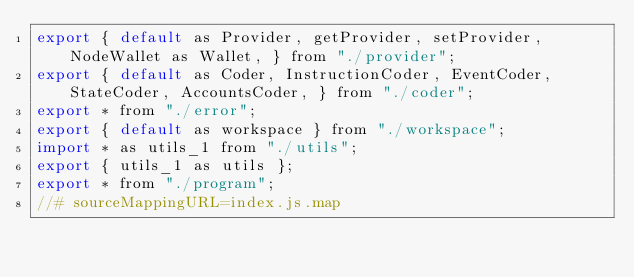Convert code to text. <code><loc_0><loc_0><loc_500><loc_500><_JavaScript_>export { default as Provider, getProvider, setProvider, NodeWallet as Wallet, } from "./provider";
export { default as Coder, InstructionCoder, EventCoder, StateCoder, AccountsCoder, } from "./coder";
export * from "./error";
export { default as workspace } from "./workspace";
import * as utils_1 from "./utils";
export { utils_1 as utils };
export * from "./program";
//# sourceMappingURL=index.js.map</code> 